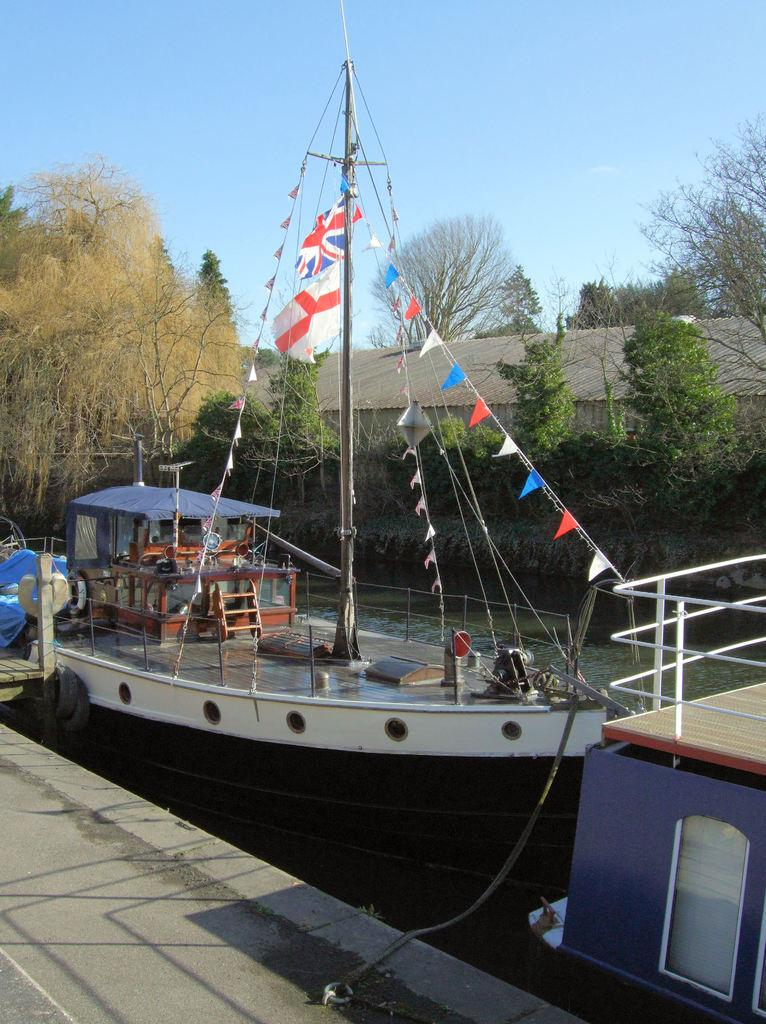What type of structures can be seen in the image? There are houses in the image. What other natural elements are present in the image? There are trees in the image. What is visible in the background of the image? The sky is visible in the image. What type of transportation can be seen on the water surface? There are ships on the water surface in the image. What additional features can be observed on the ships? There are objects on the ships, such as poles and flags. Can you describe the flight of the cub on the wing in the image? There is no cub or wing present in the image; it features houses, trees, the sky, ships, and objects on the ships. 